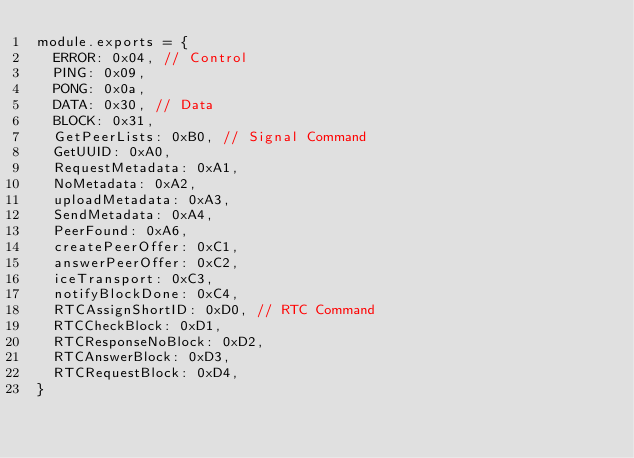<code> <loc_0><loc_0><loc_500><loc_500><_JavaScript_>module.exports = {
  ERROR: 0x04, // Control
  PING: 0x09,
  PONG: 0x0a,
  DATA: 0x30, // Data
  BLOCK: 0x31,
  GetPeerLists: 0xB0, // Signal Command
  GetUUID: 0xA0,
  RequestMetadata: 0xA1,
  NoMetadata: 0xA2,
  uploadMetadata: 0xA3,
  SendMetadata: 0xA4,
  PeerFound: 0xA6,
  createPeerOffer: 0xC1,
  answerPeerOffer: 0xC2,
  iceTransport: 0xC3,
  notifyBlockDone: 0xC4,
  RTCAssignShortID: 0xD0, // RTC Command
  RTCCheckBlock: 0xD1,
  RTCResponseNoBlock: 0xD2,
  RTCAnswerBlock: 0xD3,
  RTCRequestBlock: 0xD4,
}</code> 